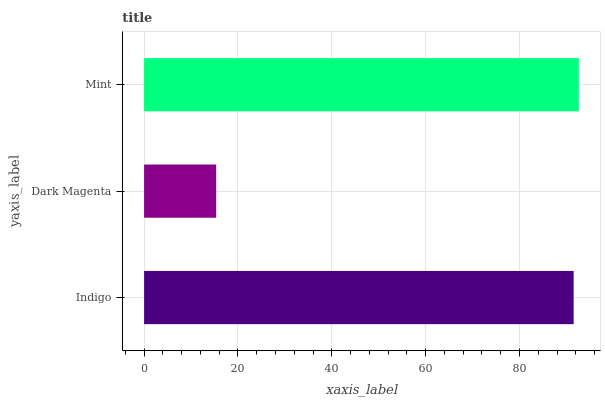Is Dark Magenta the minimum?
Answer yes or no. Yes. Is Mint the maximum?
Answer yes or no. Yes. Is Mint the minimum?
Answer yes or no. No. Is Dark Magenta the maximum?
Answer yes or no. No. Is Mint greater than Dark Magenta?
Answer yes or no. Yes. Is Dark Magenta less than Mint?
Answer yes or no. Yes. Is Dark Magenta greater than Mint?
Answer yes or no. No. Is Mint less than Dark Magenta?
Answer yes or no. No. Is Indigo the high median?
Answer yes or no. Yes. Is Indigo the low median?
Answer yes or no. Yes. Is Mint the high median?
Answer yes or no. No. Is Mint the low median?
Answer yes or no. No. 